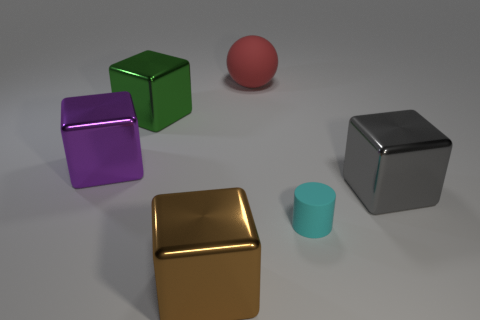Add 4 cyan cylinders. How many objects exist? 10 Subtract all purple blocks. How many blocks are left? 3 Subtract all gray cubes. How many cubes are left? 3 Subtract all cylinders. How many objects are left? 5 Subtract 0 purple balls. How many objects are left? 6 Subtract 1 cylinders. How many cylinders are left? 0 Subtract all brown blocks. Subtract all brown cylinders. How many blocks are left? 3 Subtract all gray cylinders. How many gray blocks are left? 1 Subtract all tiny red metal cylinders. Subtract all green metal blocks. How many objects are left? 5 Add 3 purple blocks. How many purple blocks are left? 4 